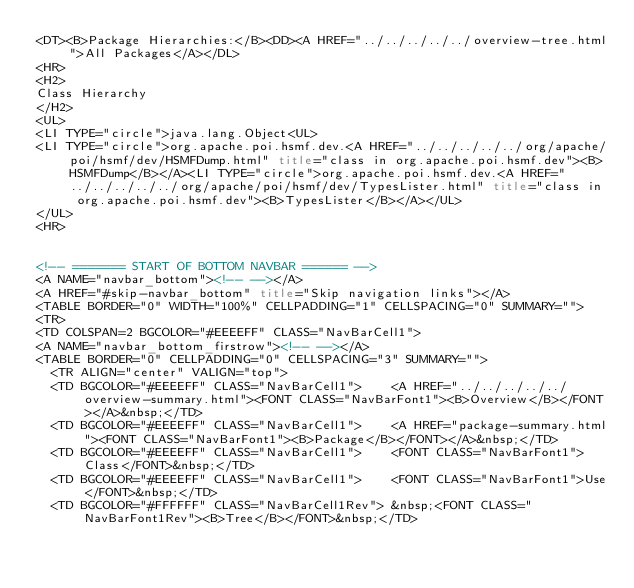Convert code to text. <code><loc_0><loc_0><loc_500><loc_500><_HTML_><DT><B>Package Hierarchies:</B><DD><A HREF="../../../../../overview-tree.html">All Packages</A></DL>
<HR>
<H2>
Class Hierarchy
</H2>
<UL>
<LI TYPE="circle">java.lang.Object<UL>
<LI TYPE="circle">org.apache.poi.hsmf.dev.<A HREF="../../../../../org/apache/poi/hsmf/dev/HSMFDump.html" title="class in org.apache.poi.hsmf.dev"><B>HSMFDump</B></A><LI TYPE="circle">org.apache.poi.hsmf.dev.<A HREF="../../../../../org/apache/poi/hsmf/dev/TypesLister.html" title="class in org.apache.poi.hsmf.dev"><B>TypesLister</B></A></UL>
</UL>
<HR>


<!-- ======= START OF BOTTOM NAVBAR ====== -->
<A NAME="navbar_bottom"><!-- --></A>
<A HREF="#skip-navbar_bottom" title="Skip navigation links"></A>
<TABLE BORDER="0" WIDTH="100%" CELLPADDING="1" CELLSPACING="0" SUMMARY="">
<TR>
<TD COLSPAN=2 BGCOLOR="#EEEEFF" CLASS="NavBarCell1">
<A NAME="navbar_bottom_firstrow"><!-- --></A>
<TABLE BORDER="0" CELLPADDING="0" CELLSPACING="3" SUMMARY="">
  <TR ALIGN="center" VALIGN="top">
  <TD BGCOLOR="#EEEEFF" CLASS="NavBarCell1">    <A HREF="../../../../../overview-summary.html"><FONT CLASS="NavBarFont1"><B>Overview</B></FONT></A>&nbsp;</TD>
  <TD BGCOLOR="#EEEEFF" CLASS="NavBarCell1">    <A HREF="package-summary.html"><FONT CLASS="NavBarFont1"><B>Package</B></FONT></A>&nbsp;</TD>
  <TD BGCOLOR="#EEEEFF" CLASS="NavBarCell1">    <FONT CLASS="NavBarFont1">Class</FONT>&nbsp;</TD>
  <TD BGCOLOR="#EEEEFF" CLASS="NavBarCell1">    <FONT CLASS="NavBarFont1">Use</FONT>&nbsp;</TD>
  <TD BGCOLOR="#FFFFFF" CLASS="NavBarCell1Rev"> &nbsp;<FONT CLASS="NavBarFont1Rev"><B>Tree</B></FONT>&nbsp;</TD></code> 